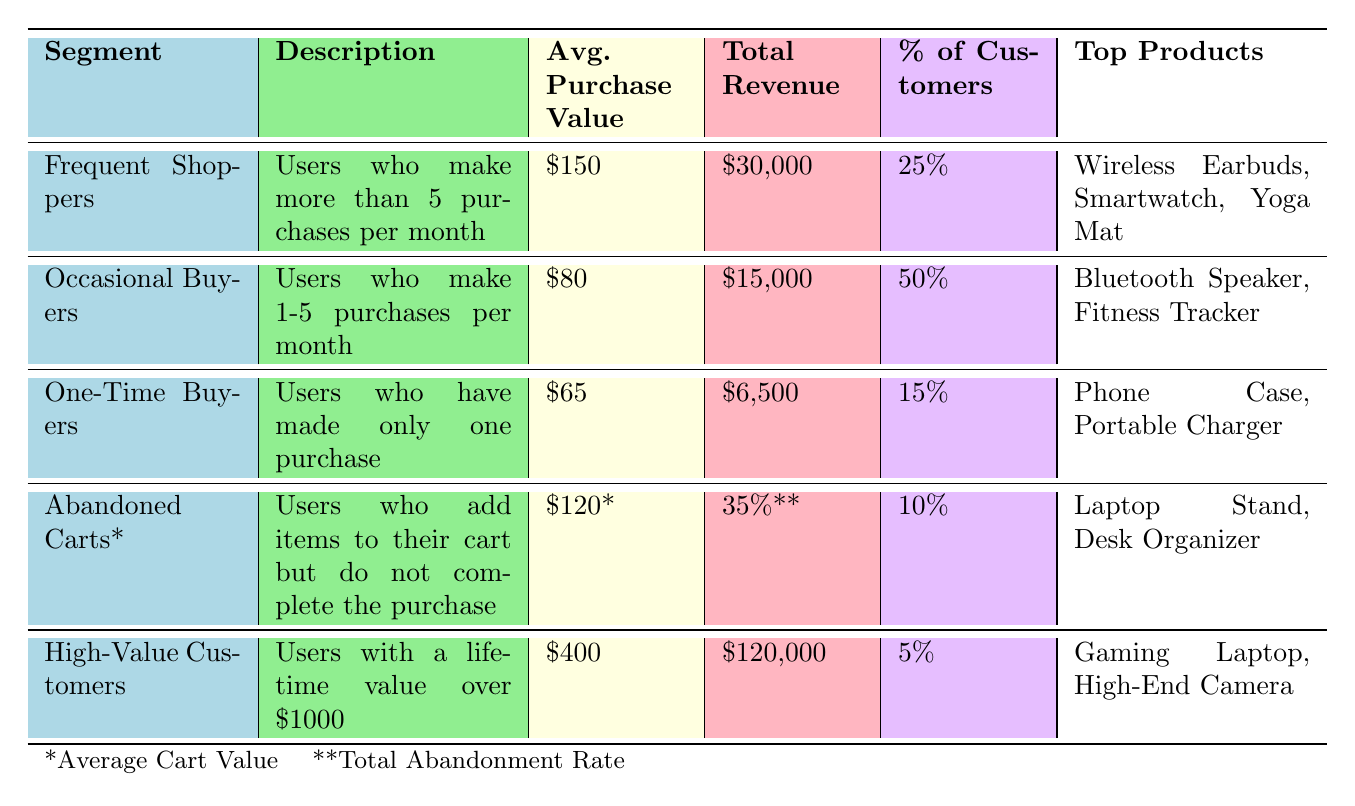What is the average purchase value for Frequent Shoppers? The average purchase value for Frequent Shoppers is directly listed in the table under the "Avg. Purchase Value" column for that segment. It states $150.
Answer: $150 How much total revenue is generated by High-Value Customers? The total revenue generated by High-Value Customers is stated in the "Total Revenue" column for that segment. It shows $120,000.
Answer: $120,000 What percentage of customers are considered One-Time Buyers? The percentage of customers who are One-Time Buyers can be found in the "Percentage of Customers" column. It is listed as 15%.
Answer: 15% Which segment has the highest average purchase value? To determine which segment has the highest average purchase value, we compare the values in the "Avg. Purchase Value" column. The highest value is $400 for High-Value Customers.
Answer: High-Value Customers What is the total revenue from Occasional Buyers and Frequent Shoppers combined? To find the total revenue from Occasional Buyers and Frequent Shoppers, we add their total revenues: $30,000 (Frequent Shoppers) + $15,000 (Occasional Buyers) = $45,000.
Answer: $45,000 Is it true that Abandoned Carts represent 10% of customers? The table states that Abandoned Carts account for 10% of customers in the "Percentage of Customers" column, confirming the fact.
Answer: Yes Which segment contributes the least total revenue? By examining the "Total Revenue" column, we find that One-Time Buyers have the least total revenue at $6,500.
Answer: One-Time Buyers What top product is common between Frequent Shoppers and Occasional Buyers? The top products listed for Frequent Shoppers are Wireless Earbuds, Smartwatch, and Yoga Mat, while for Occasional Buyers, the top products are Bluetooth Speaker and Fitness Tracker. There are no common top products.
Answer: None How many segments have an average purchase value greater than $100? We analyze the "Avg. Purchase Value" column: Frequent Shoppers ($150), High-Value Customers ($400) are above $100, giving us 2 segments.
Answer: 2 What is the difference in total revenue between High-Value Customers and One-Time Buyers? For this, we subtract the total revenue of One-Time Buyers ($6,500) from that of High-Value Customers ($120,000): $120,000 - $6,500 = $113,500.
Answer: $113,500 